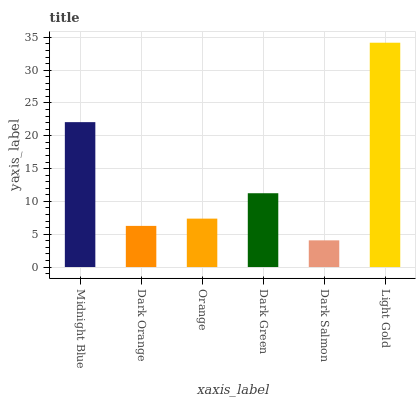Is Dark Salmon the minimum?
Answer yes or no. Yes. Is Light Gold the maximum?
Answer yes or no. Yes. Is Dark Orange the minimum?
Answer yes or no. No. Is Dark Orange the maximum?
Answer yes or no. No. Is Midnight Blue greater than Dark Orange?
Answer yes or no. Yes. Is Dark Orange less than Midnight Blue?
Answer yes or no. Yes. Is Dark Orange greater than Midnight Blue?
Answer yes or no. No. Is Midnight Blue less than Dark Orange?
Answer yes or no. No. Is Dark Green the high median?
Answer yes or no. Yes. Is Orange the low median?
Answer yes or no. Yes. Is Orange the high median?
Answer yes or no. No. Is Midnight Blue the low median?
Answer yes or no. No. 